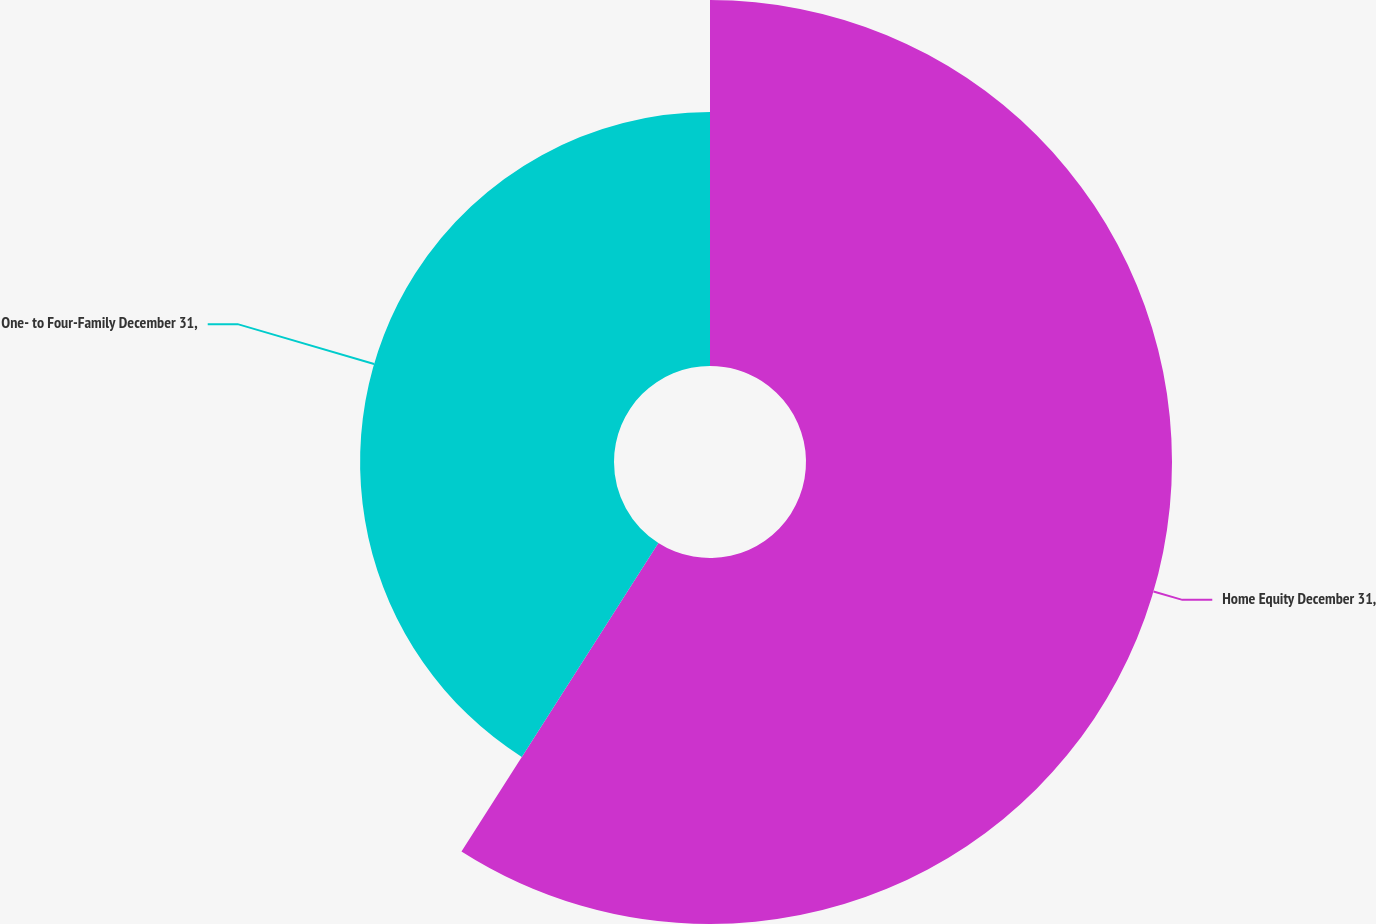<chart> <loc_0><loc_0><loc_500><loc_500><pie_chart><fcel>Home Equity December 31,<fcel>One- to Four-Family December 31,<nl><fcel>59.04%<fcel>40.96%<nl></chart> 